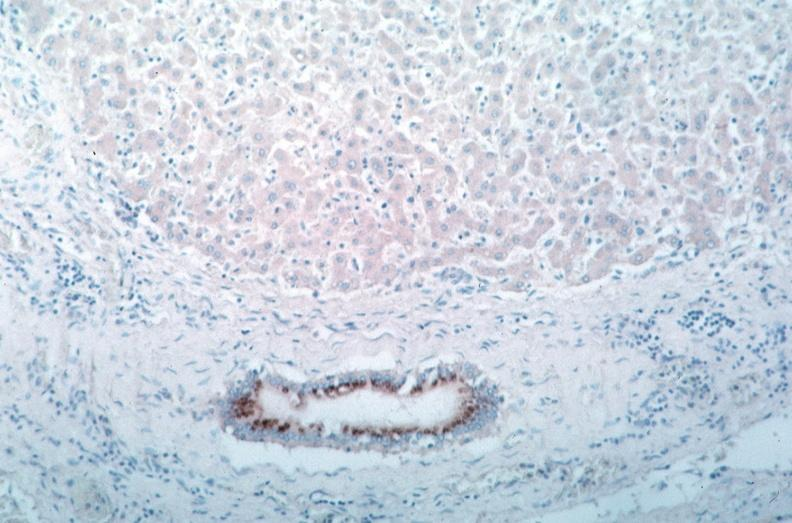s cardiovascular present?
Answer the question using a single word or phrase. Yes 